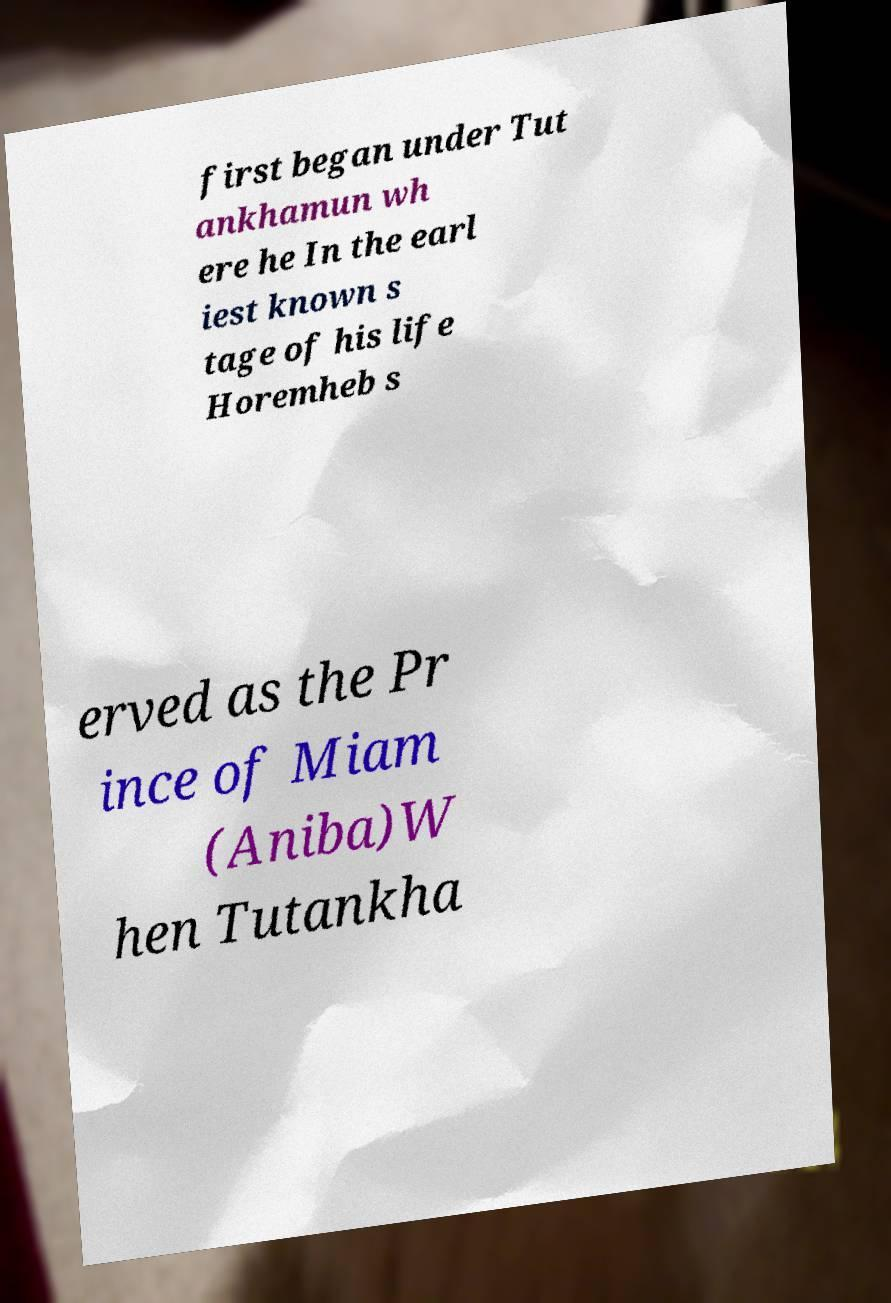For documentation purposes, I need the text within this image transcribed. Could you provide that? first began under Tut ankhamun wh ere he In the earl iest known s tage of his life Horemheb s erved as the Pr ince of Miam (Aniba)W hen Tutankha 